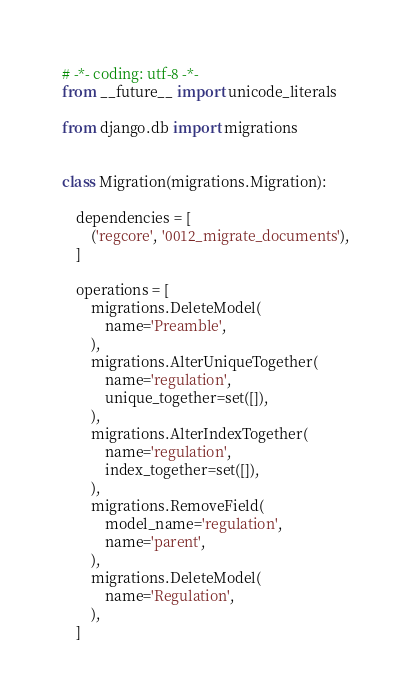Convert code to text. <code><loc_0><loc_0><loc_500><loc_500><_Python_># -*- coding: utf-8 -*-
from __future__ import unicode_literals

from django.db import migrations


class Migration(migrations.Migration):

    dependencies = [
        ('regcore', '0012_migrate_documents'),
    ]

    operations = [
        migrations.DeleteModel(
            name='Preamble',
        ),
        migrations.AlterUniqueTogether(
            name='regulation',
            unique_together=set([]),
        ),
        migrations.AlterIndexTogether(
            name='regulation',
            index_together=set([]),
        ),
        migrations.RemoveField(
            model_name='regulation',
            name='parent',
        ),
        migrations.DeleteModel(
            name='Regulation',
        ),
    ]
</code> 